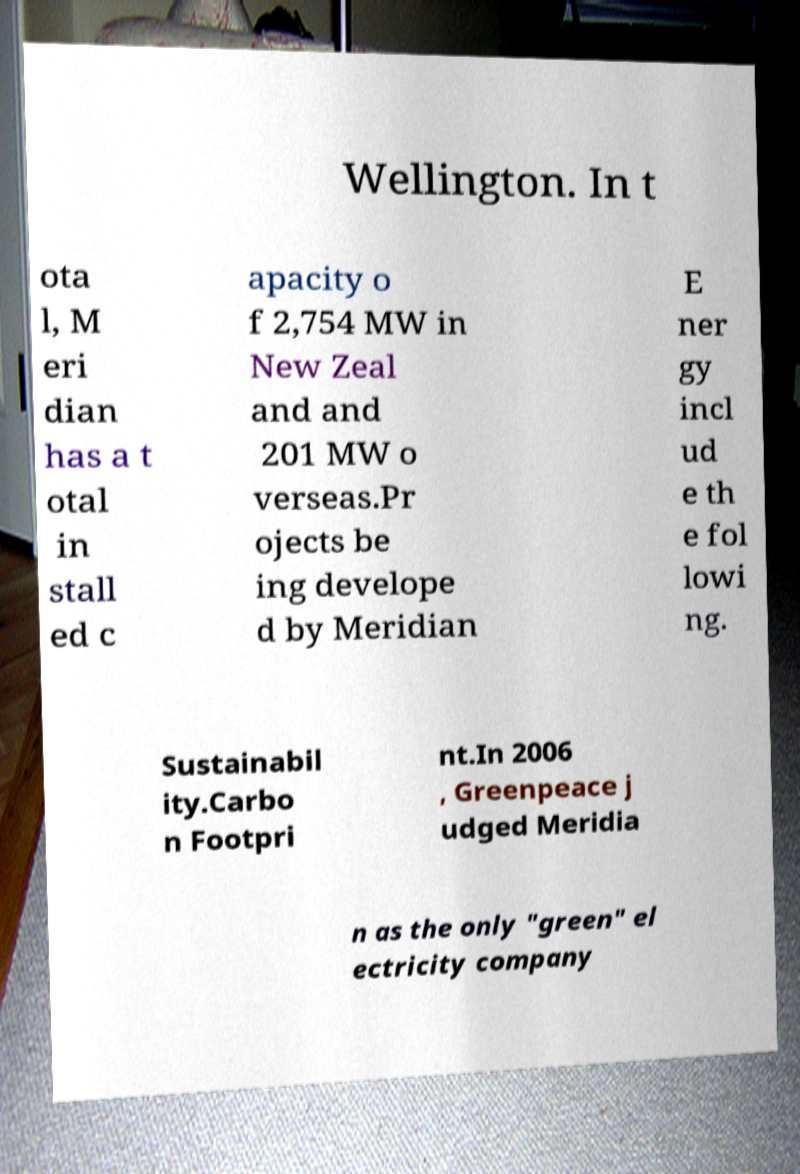Please identify and transcribe the text found in this image. Wellington. In t ota l, M eri dian has a t otal in stall ed c apacity o f 2,754 MW in New Zeal and and 201 MW o verseas.Pr ojects be ing develope d by Meridian E ner gy incl ud e th e fol lowi ng. Sustainabil ity.Carbo n Footpri nt.In 2006 , Greenpeace j udged Meridia n as the only "green" el ectricity company 